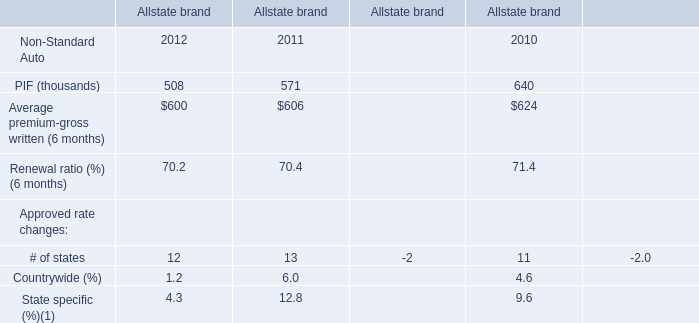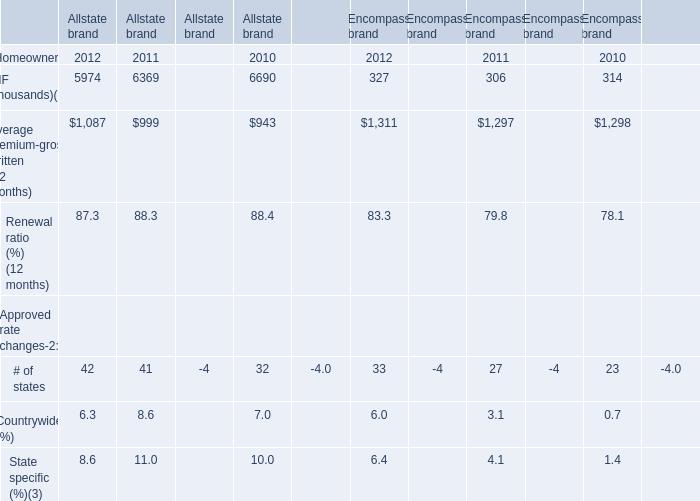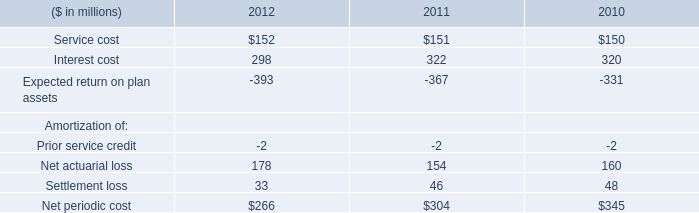What's the total amount of the State specific in the years where Countrywide is greater than 4? (in %) 
Computations: (4.3 + 9.6)
Answer: 13.9. 